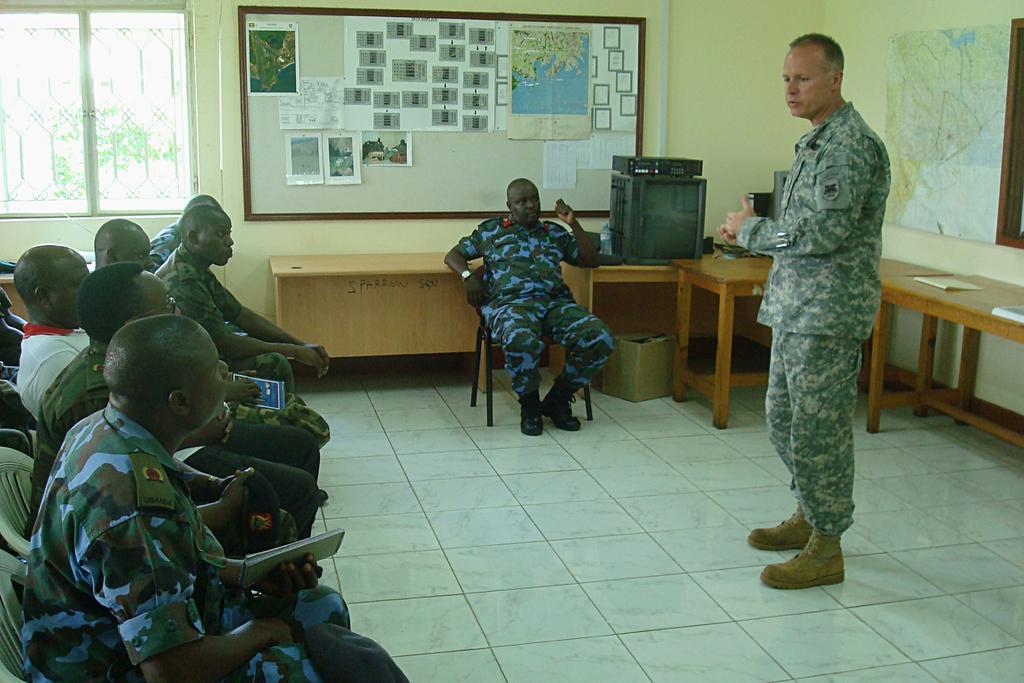Please provide a concise description of this image. This picture shows a group of people seated on the chairs and we see a man standing and speaking and we see a notice board and couple of tables and a map on the wall 